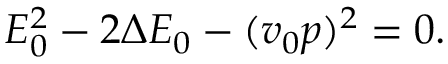Convert formula to latex. <formula><loc_0><loc_0><loc_500><loc_500>\begin{array} { r } { E _ { 0 } ^ { 2 } - 2 \Delta E _ { 0 } - ( v _ { 0 } p ) ^ { 2 } = 0 . } \end{array}</formula> 